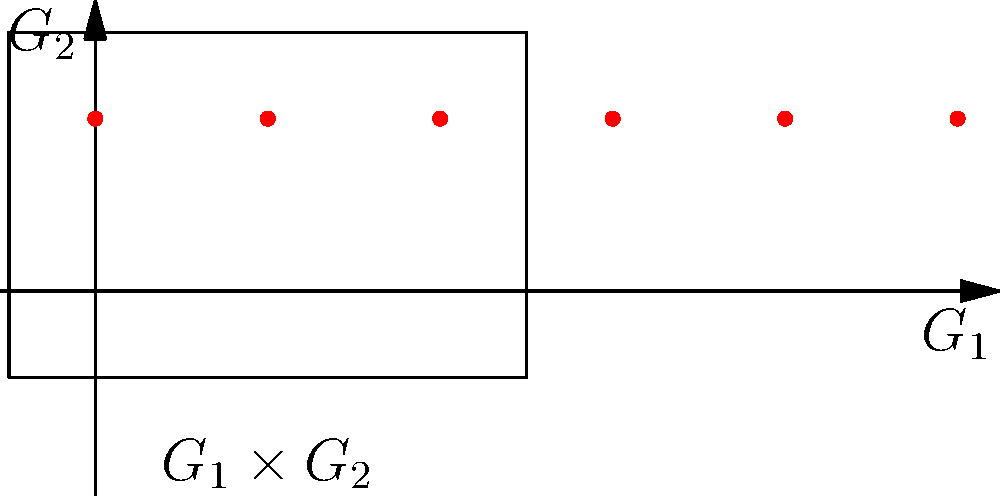In WooCommerce, you're implementing a multi-criteria sorting function for products. The first criterion (price) has 3 options, and the second criterion (rating) has 4 options. If we represent these as groups $G_1$ and $G_2$ respectively, what is the order of the direct product group $G_1 \times G_2$, which represents all possible sorting combinations? To solve this problem, we'll follow these steps:

1. Identify the orders of the individual groups:
   - $G_1$ (price sorting) has 3 options, so $|G_1| = 3$
   - $G_2$ (rating sorting) has 4 options, so $|G_2| = 4$

2. Recall the theorem for the order of a direct product of groups:
   For finite groups $A$ and $B$, $|A \times B| = |A| \cdot |B|$

3. Apply the theorem to our specific case:
   $|G_1 \times G_2| = |G_1| \cdot |G_2| = 3 \cdot 4 = 12$

4. Interpret the result:
   The direct product group $G_1 \times G_2$ has 12 elements, which represents all possible combinations of sorting options when considering both price and rating criteria.

5. Verify visually:
   In the provided diagram, we can count 12 red dots, each representing a unique combination of sorting options from $G_1$ and $G_2$.

Therefore, the order of the direct product group $G_1 \times G_2$ is 12, giving us the total number of sorting combinations available in our WooCommerce multi-criteria sorting function.
Answer: 12 